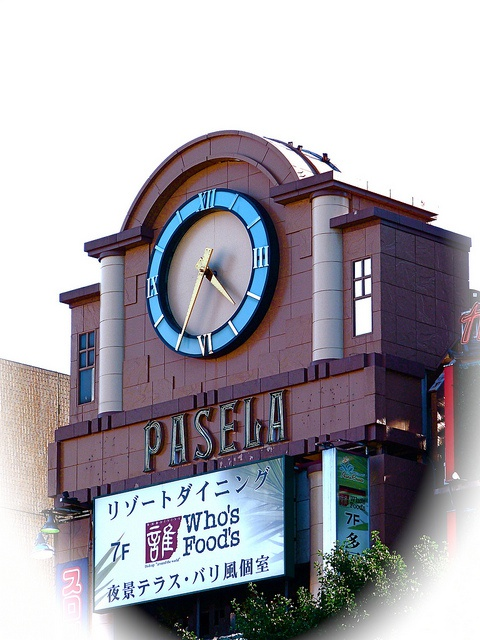Describe the objects in this image and their specific colors. I can see a clock in white, darkgray, lightblue, and black tones in this image. 